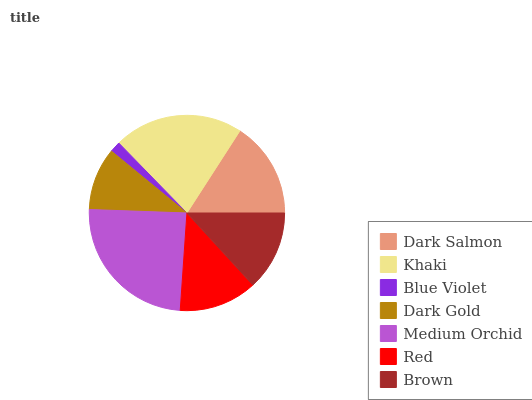Is Blue Violet the minimum?
Answer yes or no. Yes. Is Medium Orchid the maximum?
Answer yes or no. Yes. Is Khaki the minimum?
Answer yes or no. No. Is Khaki the maximum?
Answer yes or no. No. Is Khaki greater than Dark Salmon?
Answer yes or no. Yes. Is Dark Salmon less than Khaki?
Answer yes or no. Yes. Is Dark Salmon greater than Khaki?
Answer yes or no. No. Is Khaki less than Dark Salmon?
Answer yes or no. No. Is Brown the high median?
Answer yes or no. Yes. Is Brown the low median?
Answer yes or no. Yes. Is Red the high median?
Answer yes or no. No. Is Medium Orchid the low median?
Answer yes or no. No. 